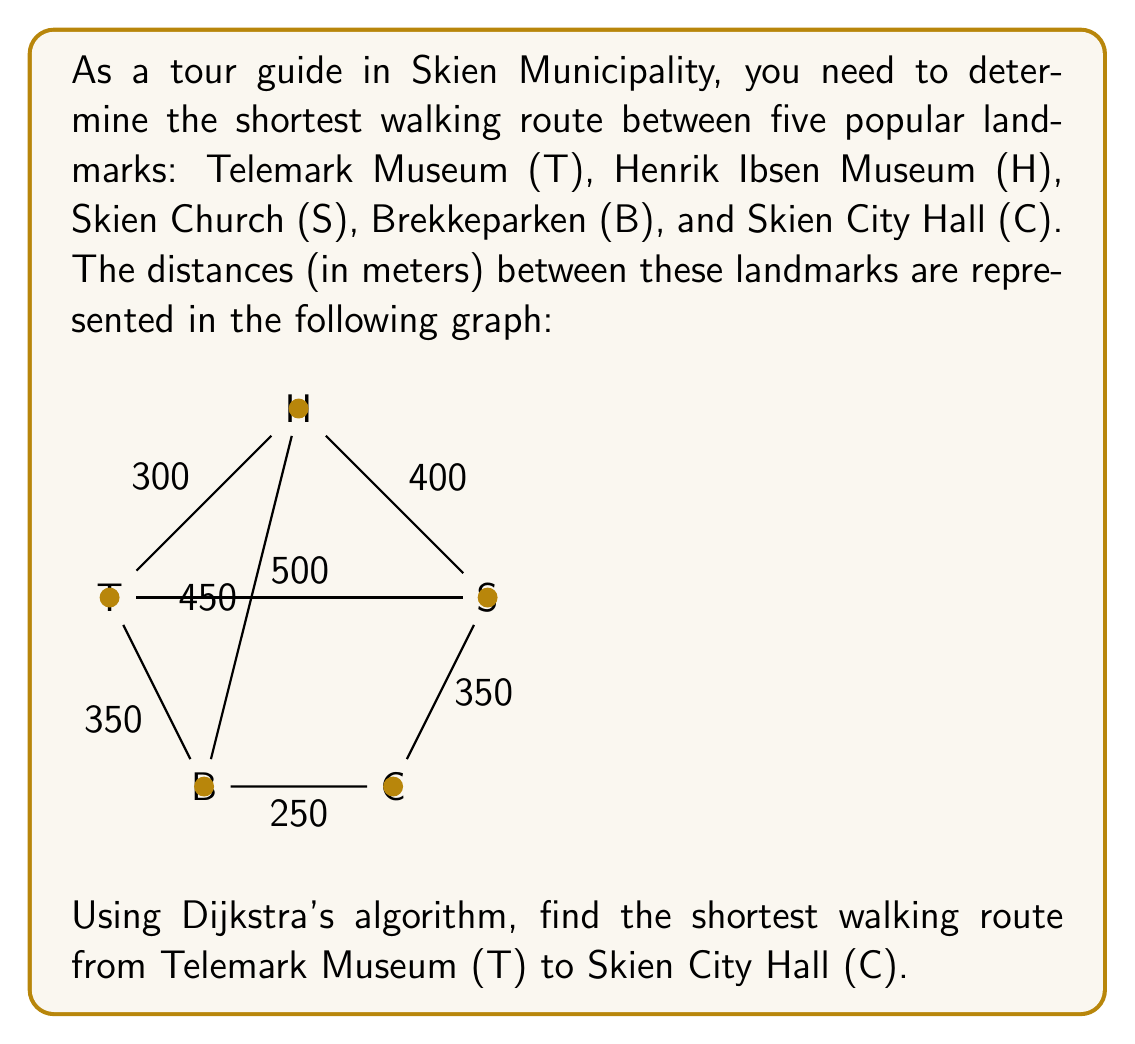Show me your answer to this math problem. To solve this problem using Dijkstra's algorithm, we'll follow these steps:

1) Initialize:
   - Set distance to T as 0, and all others as infinity.
   - Set T as the current node.
   - Mark all nodes as unvisited.

2) For the current node, consider all its unvisited neighbors and calculate their tentative distances.
3) Mark the current node as visited. A visited node will not be checked again.
4) If the destination node (C) has been marked visited, we're done.
5) Otherwise, select the unvisited node with the smallest tentative distance, and set it as the new current node. Go back to step 2.

Let's apply the algorithm:

1) Start at T: distance(T) = 0, others = ∞
   Current node: T
   Unvisited: {T, H, S, B, C}

2) Update neighbors of T:
   distance(H) = min(∞, 0 + 300) = 300
   distance(S) = min(∞, 0 + 500) = 500
   distance(B) = min(∞, 0 + 350) = 350

3) Mark T as visited. Select H (smallest distance).
   Current node: H
   Unvisited: {H, S, B, C}

4) Update neighbors of H:
   distance(S) = min(500, 300 + 400) = 500
   distance(B) = min(350, 300 + 450) = 350

5) Mark H as visited. Select B (smallest distance).
   Current node: B
   Unvisited: {S, B, C}

6) Update neighbors of B:
   distance(C) = min(∞, 350 + 250) = 600

7) Mark B as visited. Select S (smallest distance).
   Current node: S
   Unvisited: {S, C}

8) Update neighbors of S:
   distance(C) = min(600, 500 + 350) = 600

9) Mark S as visited. Select C (only unvisited node left).
   Current node: C
   Unvisited: {C}

10) Mark C as visited. Algorithm complete.

The shortest path from T to C is T → B → C with a total distance of 600 meters.
Answer: T → B → C, 600 meters 